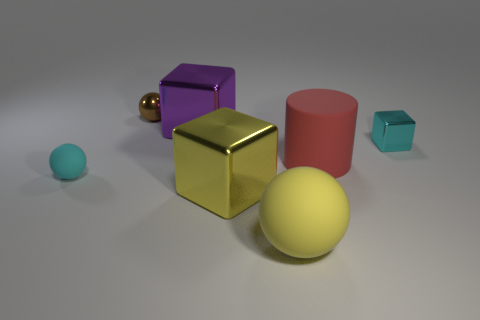What material is the tiny thing right of the large metal object that is behind the cyan thing on the right side of the red rubber cylinder made of?
Make the answer very short. Metal. Are there more matte things that are on the left side of the small brown ball than rubber cylinders that are to the right of the big red matte cylinder?
Provide a short and direct response. Yes. What number of things are the same material as the small cube?
Your response must be concise. 3. There is a big rubber object in front of the large rubber cylinder; is it the same shape as the small object that is behind the big purple metal object?
Ensure brevity in your answer.  Yes. What is the color of the large cube that is behind the red thing?
Offer a terse response. Purple. Is there a small cyan object of the same shape as the large purple object?
Ensure brevity in your answer.  Yes. What is the red object made of?
Your answer should be very brief. Rubber. There is a matte thing that is behind the large yellow cube and to the right of the brown object; what is its size?
Your response must be concise. Large. What is the material of the object that is the same color as the tiny shiny block?
Your answer should be very brief. Rubber. How many tiny green cubes are there?
Your answer should be very brief. 0. 